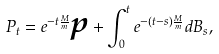<formula> <loc_0><loc_0><loc_500><loc_500>P _ { t } = e ^ { - t \frac { M } { m } } \boldsymbol p + \int _ { 0 } ^ { t } e ^ { - ( t - s ) \frac { M } { m } } d B _ { s } ,</formula> 